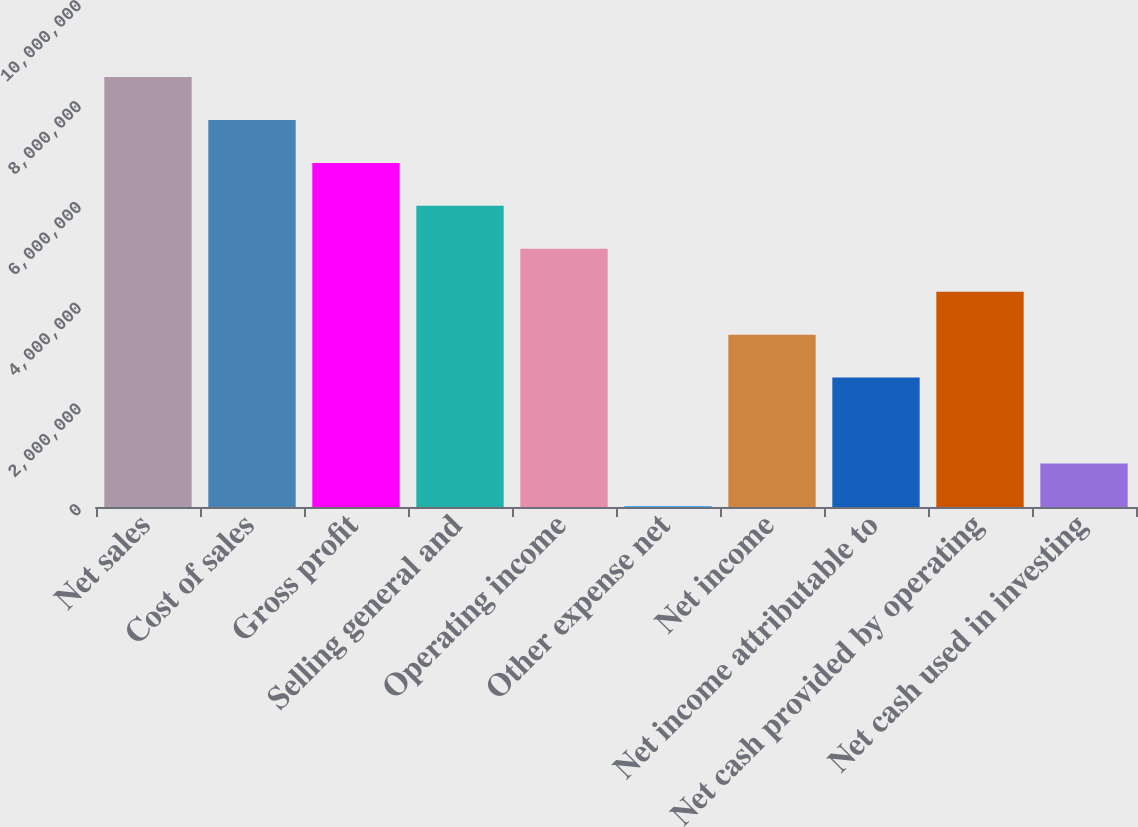Convert chart to OTSL. <chart><loc_0><loc_0><loc_500><loc_500><bar_chart><fcel>Net sales<fcel>Cost of sales<fcel>Gross profit<fcel>Selling general and<fcel>Operating income<fcel>Other expense net<fcel>Net income<fcel>Net income attributable to<fcel>Net cash provided by operating<fcel>Net cash used in investing<nl><fcel>8.53024e+06<fcel>7.6785e+06<fcel>6.82676e+06<fcel>5.97502e+06<fcel>5.12328e+06<fcel>12842<fcel>3.4198e+06<fcel>2.56806e+06<fcel>4.27154e+06<fcel>864582<nl></chart> 